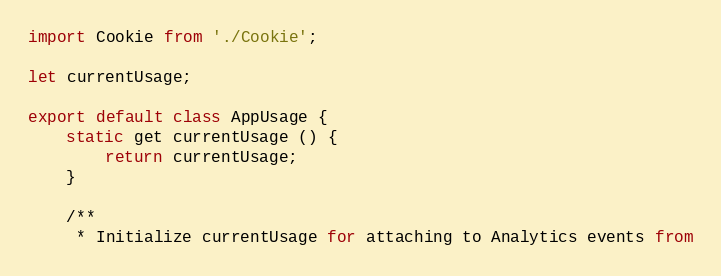Convert code to text. <code><loc_0><loc_0><loc_500><loc_500><_JavaScript_>import Cookie from './Cookie';

let currentUsage;

export default class AppUsage {
    static get currentUsage () {
        return currentUsage;
    }
    
    /**
     * Initialize currentUsage for attaching to Analytics events from</code> 